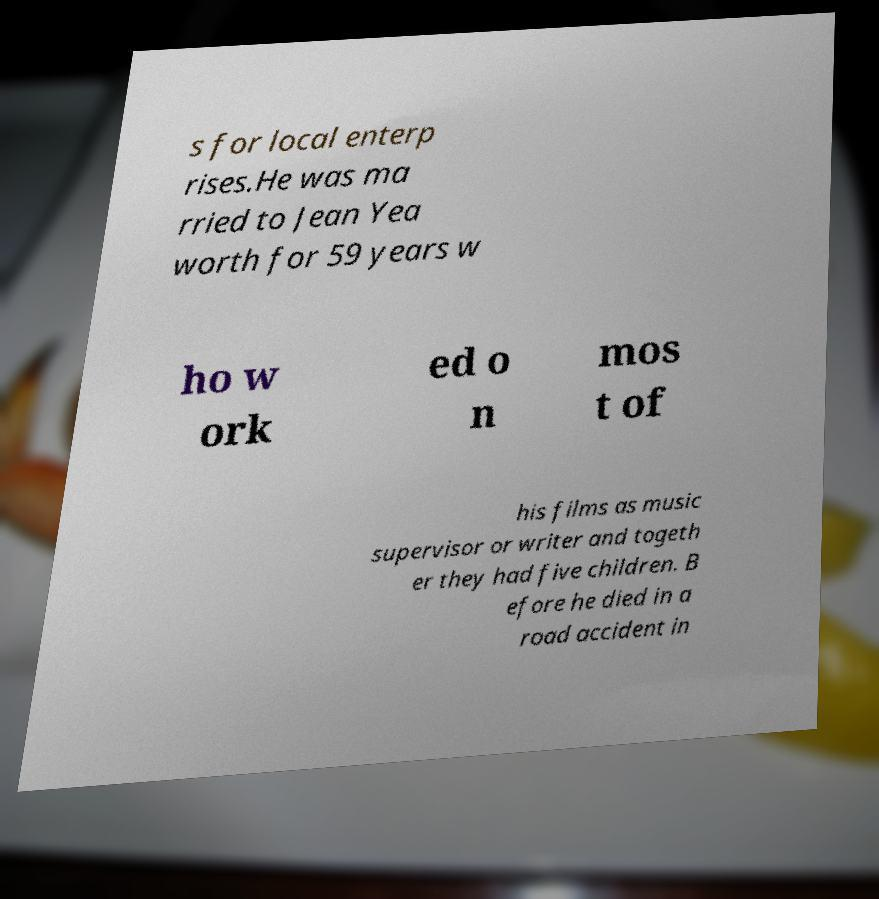Can you read and provide the text displayed in the image?This photo seems to have some interesting text. Can you extract and type it out for me? s for local enterp rises.He was ma rried to Jean Yea worth for 59 years w ho w ork ed o n mos t of his films as music supervisor or writer and togeth er they had five children. B efore he died in a road accident in 